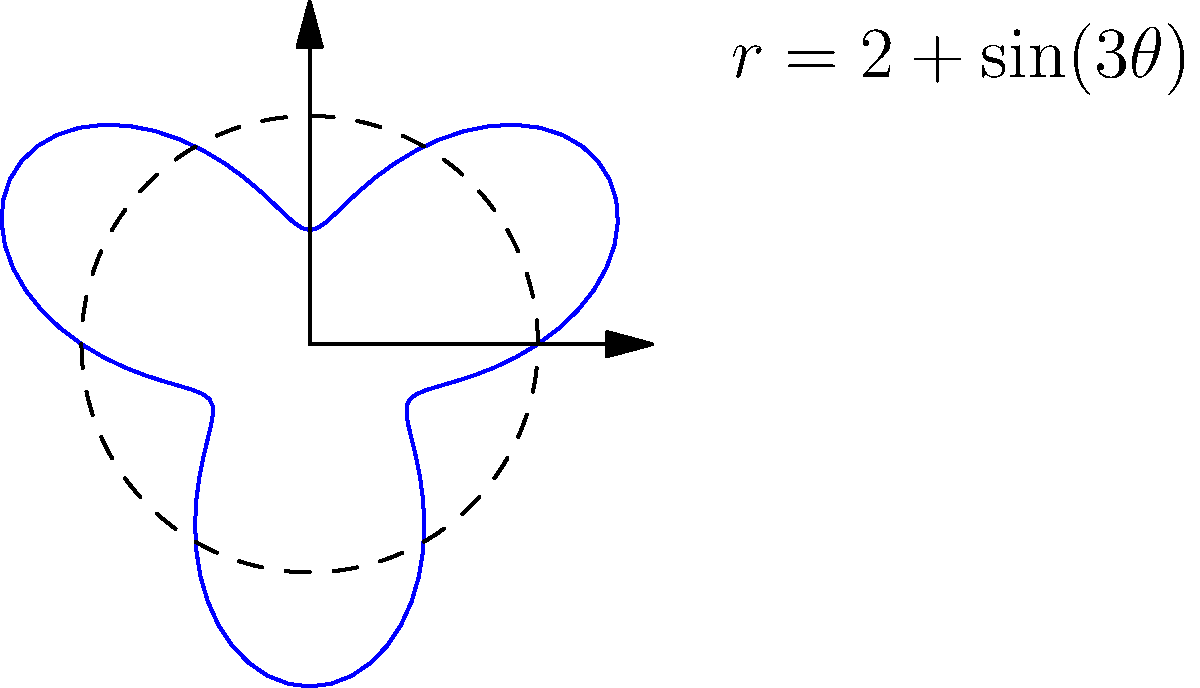On the planet Zircon-9, scientists have discovered that its surface can be modeled using polar coordinates with the equation $r = 2 + \sin(3\theta)$, where $r$ is measured in thousands of kilometers. Calculate the total surface area of Zircon-9 in millions of square kilometers. To find the surface area using polar coordinates, we need to use the formula:

$$A = \frac{1}{2} \int_{0}^{2\pi} r^2 d\theta$$

Step 1: Substitute the given equation for $r$:
$$A = \frac{1}{2} \int_{0}^{2\pi} (2 + \sin(3\theta))^2 d\theta$$

Step 2: Expand the integrand:
$$A = \frac{1}{2} \int_{0}^{2\pi} (4 + 4\sin(3\theta) + \sin^2(3\theta)) d\theta$$

Step 3: Use the trigonometric identity $\sin^2(x) = \frac{1 - \cos(2x)}{2}$:
$$A = \frac{1}{2} \int_{0}^{2\pi} (4 + 4\sin(3\theta) + \frac{1 - \cos(6\theta)}{2}) d\theta$$

Step 4: Simplify:
$$A = \frac{1}{2} \int_{0}^{2\pi} (4.5 + 4\sin(3\theta) - \frac{1}{2}\cos(6\theta)) d\theta$$

Step 5: Integrate term by term:
$$A = \frac{1}{2} [4.5\theta - \frac{4}{3}\cos(3\theta) - \frac{1}{12}\sin(6\theta)]_{0}^{2\pi}$$

Step 6: Evaluate the definite integral:
$$A = \frac{1}{2} [(4.5 \cdot 2\pi - \frac{4}{3} + \frac{4}{3}) - (0 - \frac{4}{3} + \frac{4}{3})]$$

Step 7: Simplify:
$$A = \frac{1}{2} (4.5 \cdot 2\pi) = 4.5\pi$$

Step 8: Convert units (remember $r$ was in thousands of km):
$$A = 4.5\pi \cdot 1,000,000 \text{ km}^2 = 14.137 \text{ million km}^2$$
Answer: 14.137 million km² 